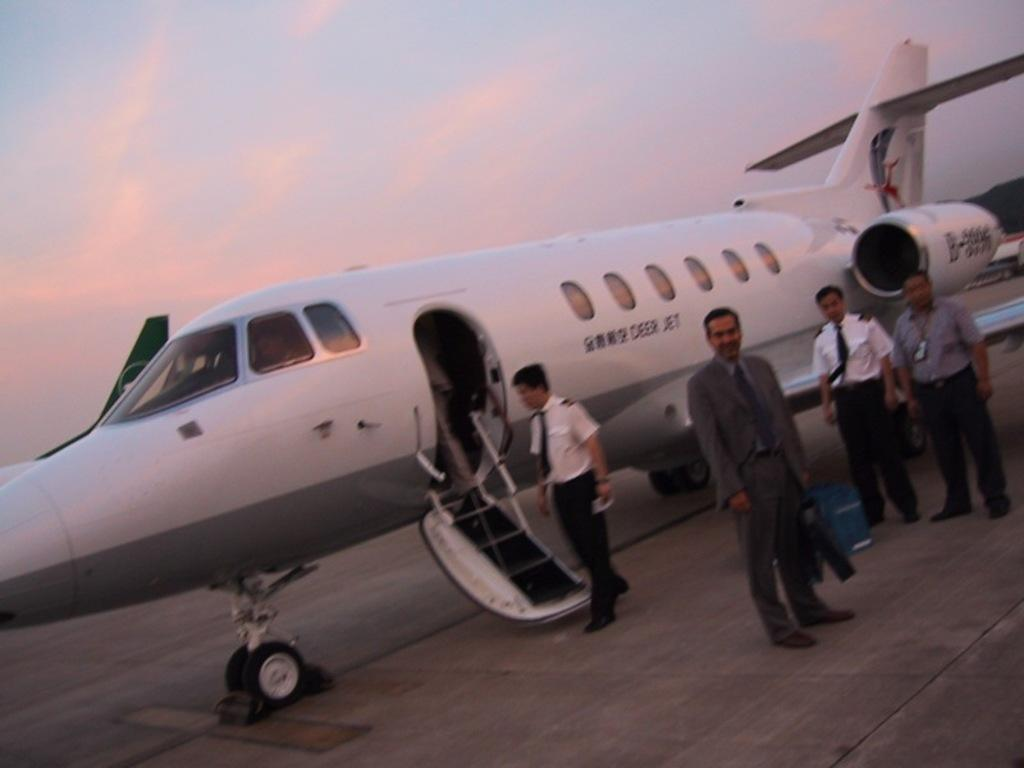What is the main subject of the picture? The main subject of the picture is an airplane. Do the airplane have any specific features? Yes, the airplane has windows and wings. What are the people near the airplane doing? The people standing near the airplane are holding suitcases. What is the condition of the sky in the picture? The sky is clear in the picture. What type of clam can be seen holding a position in the image? There is no clam present in the image, and therefore no such activity can be observed. What type of silk is draped over the airplane in the image? There is no silk present in the image; it features an airplane with people holding suitcases near it. 